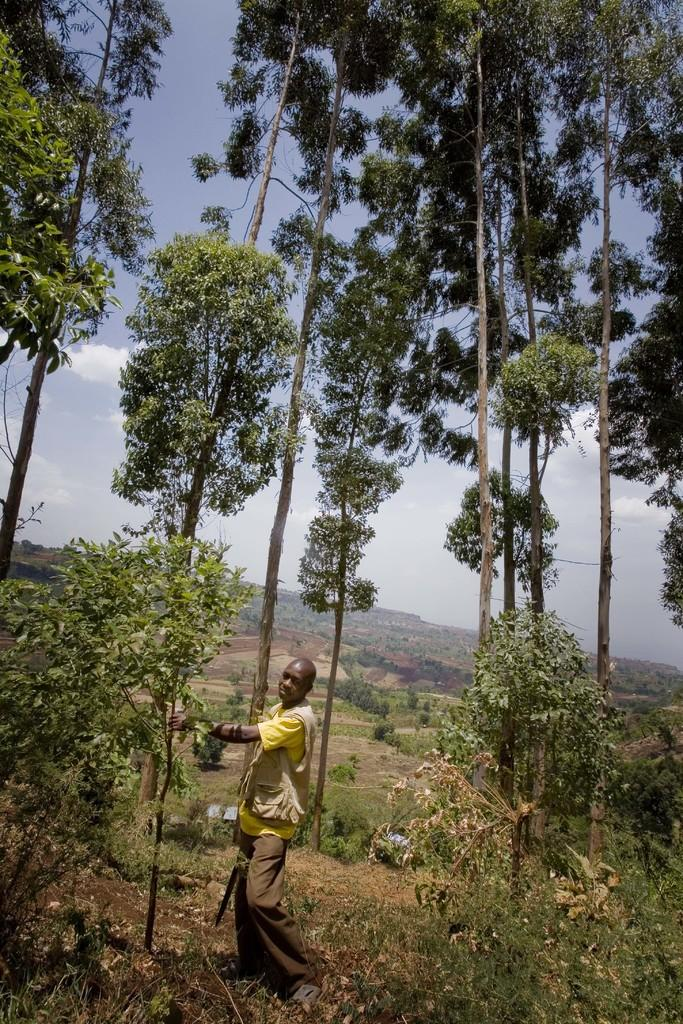What is the main subject of the image? There is a person standing in the image. What type of natural environment is present in the image? There are trees in the image. What can be seen in the background of the image? The sky is visible in the background of the image. What type of space expert can be seen in the image? There is no space expert present in the image; it features a person standing in front of trees with the sky visible in the background. Can you tell me how many matches are visible in the image? There are no matches present in the image. 